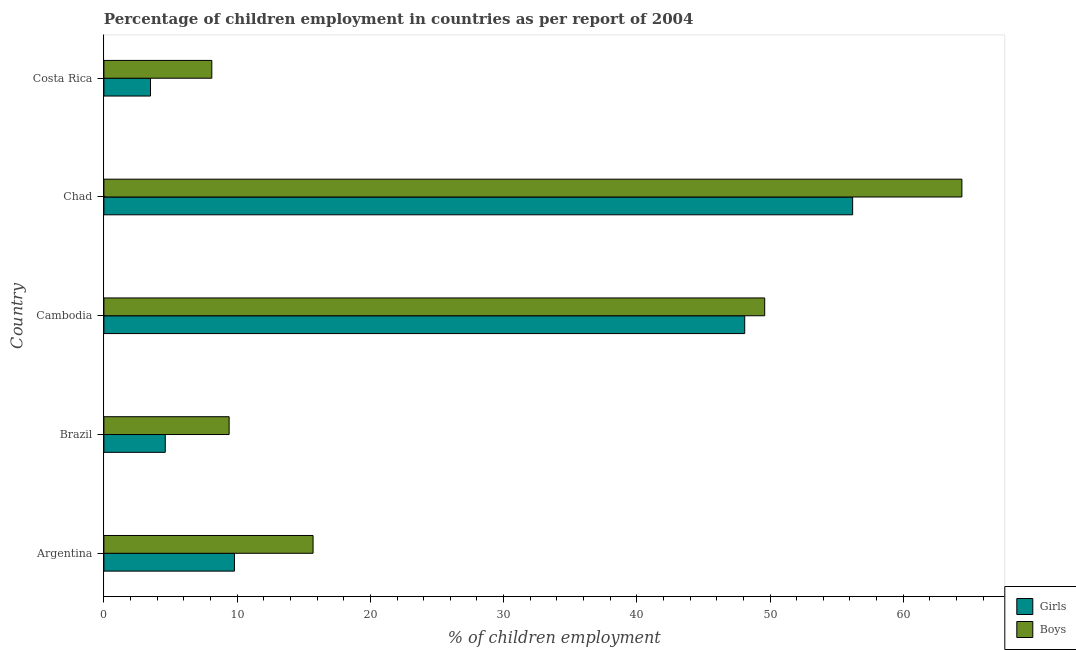How many different coloured bars are there?
Provide a short and direct response. 2. How many bars are there on the 1st tick from the top?
Make the answer very short. 2. How many bars are there on the 3rd tick from the bottom?
Your answer should be very brief. 2. What is the label of the 2nd group of bars from the top?
Provide a short and direct response. Chad. Across all countries, what is the maximum percentage of employed boys?
Provide a short and direct response. 64.4. In which country was the percentage of employed boys maximum?
Offer a very short reply. Chad. In which country was the percentage of employed boys minimum?
Your response must be concise. Costa Rica. What is the total percentage of employed boys in the graph?
Your answer should be very brief. 147.2. What is the difference between the percentage of employed girls in Costa Rica and the percentage of employed boys in Chad?
Provide a short and direct response. -60.9. What is the average percentage of employed boys per country?
Your response must be concise. 29.44. What is the ratio of the percentage of employed girls in Brazil to that in Costa Rica?
Make the answer very short. 1.32. What is the difference between the highest and the lowest percentage of employed girls?
Your response must be concise. 52.7. In how many countries, is the percentage of employed girls greater than the average percentage of employed girls taken over all countries?
Provide a short and direct response. 2. Is the sum of the percentage of employed boys in Cambodia and Costa Rica greater than the maximum percentage of employed girls across all countries?
Your answer should be very brief. Yes. What does the 1st bar from the top in Brazil represents?
Keep it short and to the point. Boys. What does the 1st bar from the bottom in Chad represents?
Keep it short and to the point. Girls. Are all the bars in the graph horizontal?
Make the answer very short. Yes. How many countries are there in the graph?
Give a very brief answer. 5. What is the difference between two consecutive major ticks on the X-axis?
Give a very brief answer. 10. Does the graph contain any zero values?
Make the answer very short. No. Does the graph contain grids?
Provide a succinct answer. No. How many legend labels are there?
Make the answer very short. 2. How are the legend labels stacked?
Ensure brevity in your answer.  Vertical. What is the title of the graph?
Offer a very short reply. Percentage of children employment in countries as per report of 2004. Does "From human activities" appear as one of the legend labels in the graph?
Provide a succinct answer. No. What is the label or title of the X-axis?
Offer a very short reply. % of children employment. What is the label or title of the Y-axis?
Make the answer very short. Country. What is the % of children employment of Girls in Argentina?
Ensure brevity in your answer.  9.8. What is the % of children employment in Boys in Argentina?
Provide a succinct answer. 15.7. What is the % of children employment in Girls in Brazil?
Offer a very short reply. 4.61. What is the % of children employment in Girls in Cambodia?
Make the answer very short. 48.1. What is the % of children employment in Boys in Cambodia?
Make the answer very short. 49.6. What is the % of children employment of Girls in Chad?
Provide a short and direct response. 56.2. What is the % of children employment in Boys in Chad?
Make the answer very short. 64.4. Across all countries, what is the maximum % of children employment of Girls?
Offer a very short reply. 56.2. Across all countries, what is the maximum % of children employment in Boys?
Make the answer very short. 64.4. Across all countries, what is the minimum % of children employment of Girls?
Ensure brevity in your answer.  3.5. Across all countries, what is the minimum % of children employment of Boys?
Your response must be concise. 8.1. What is the total % of children employment in Girls in the graph?
Keep it short and to the point. 122.21. What is the total % of children employment of Boys in the graph?
Your answer should be compact. 147.2. What is the difference between the % of children employment of Girls in Argentina and that in Brazil?
Give a very brief answer. 5.19. What is the difference between the % of children employment in Girls in Argentina and that in Cambodia?
Make the answer very short. -38.3. What is the difference between the % of children employment of Boys in Argentina and that in Cambodia?
Offer a terse response. -33.9. What is the difference between the % of children employment of Girls in Argentina and that in Chad?
Offer a terse response. -46.4. What is the difference between the % of children employment in Boys in Argentina and that in Chad?
Offer a terse response. -48.7. What is the difference between the % of children employment of Girls in Argentina and that in Costa Rica?
Provide a short and direct response. 6.3. What is the difference between the % of children employment in Boys in Argentina and that in Costa Rica?
Your answer should be compact. 7.6. What is the difference between the % of children employment in Girls in Brazil and that in Cambodia?
Provide a short and direct response. -43.49. What is the difference between the % of children employment in Boys in Brazil and that in Cambodia?
Provide a short and direct response. -40.2. What is the difference between the % of children employment of Girls in Brazil and that in Chad?
Offer a terse response. -51.59. What is the difference between the % of children employment of Boys in Brazil and that in Chad?
Offer a terse response. -55. What is the difference between the % of children employment in Girls in Brazil and that in Costa Rica?
Provide a short and direct response. 1.11. What is the difference between the % of children employment in Boys in Brazil and that in Costa Rica?
Your response must be concise. 1.3. What is the difference between the % of children employment of Girls in Cambodia and that in Chad?
Your answer should be very brief. -8.1. What is the difference between the % of children employment of Boys in Cambodia and that in Chad?
Keep it short and to the point. -14.8. What is the difference between the % of children employment of Girls in Cambodia and that in Costa Rica?
Give a very brief answer. 44.6. What is the difference between the % of children employment of Boys in Cambodia and that in Costa Rica?
Give a very brief answer. 41.5. What is the difference between the % of children employment in Girls in Chad and that in Costa Rica?
Make the answer very short. 52.7. What is the difference between the % of children employment of Boys in Chad and that in Costa Rica?
Your answer should be compact. 56.3. What is the difference between the % of children employment of Girls in Argentina and the % of children employment of Boys in Cambodia?
Your answer should be compact. -39.8. What is the difference between the % of children employment of Girls in Argentina and the % of children employment of Boys in Chad?
Give a very brief answer. -54.6. What is the difference between the % of children employment in Girls in Brazil and the % of children employment in Boys in Cambodia?
Offer a terse response. -44.99. What is the difference between the % of children employment in Girls in Brazil and the % of children employment in Boys in Chad?
Make the answer very short. -59.79. What is the difference between the % of children employment of Girls in Brazil and the % of children employment of Boys in Costa Rica?
Ensure brevity in your answer.  -3.49. What is the difference between the % of children employment in Girls in Cambodia and the % of children employment in Boys in Chad?
Provide a succinct answer. -16.3. What is the difference between the % of children employment of Girls in Cambodia and the % of children employment of Boys in Costa Rica?
Offer a terse response. 40. What is the difference between the % of children employment in Girls in Chad and the % of children employment in Boys in Costa Rica?
Provide a short and direct response. 48.1. What is the average % of children employment of Girls per country?
Make the answer very short. 24.44. What is the average % of children employment of Boys per country?
Your response must be concise. 29.44. What is the difference between the % of children employment in Girls and % of children employment in Boys in Brazil?
Make the answer very short. -4.79. What is the difference between the % of children employment of Girls and % of children employment of Boys in Cambodia?
Offer a very short reply. -1.5. What is the difference between the % of children employment in Girls and % of children employment in Boys in Chad?
Provide a short and direct response. -8.2. What is the ratio of the % of children employment of Girls in Argentina to that in Brazil?
Provide a succinct answer. 2.13. What is the ratio of the % of children employment in Boys in Argentina to that in Brazil?
Give a very brief answer. 1.67. What is the ratio of the % of children employment in Girls in Argentina to that in Cambodia?
Ensure brevity in your answer.  0.2. What is the ratio of the % of children employment in Boys in Argentina to that in Cambodia?
Your response must be concise. 0.32. What is the ratio of the % of children employment in Girls in Argentina to that in Chad?
Keep it short and to the point. 0.17. What is the ratio of the % of children employment of Boys in Argentina to that in Chad?
Your response must be concise. 0.24. What is the ratio of the % of children employment of Boys in Argentina to that in Costa Rica?
Give a very brief answer. 1.94. What is the ratio of the % of children employment in Girls in Brazil to that in Cambodia?
Make the answer very short. 0.1. What is the ratio of the % of children employment of Boys in Brazil to that in Cambodia?
Provide a succinct answer. 0.19. What is the ratio of the % of children employment of Girls in Brazil to that in Chad?
Make the answer very short. 0.08. What is the ratio of the % of children employment in Boys in Brazil to that in Chad?
Provide a short and direct response. 0.15. What is the ratio of the % of children employment in Girls in Brazil to that in Costa Rica?
Your answer should be very brief. 1.32. What is the ratio of the % of children employment in Boys in Brazil to that in Costa Rica?
Provide a short and direct response. 1.16. What is the ratio of the % of children employment in Girls in Cambodia to that in Chad?
Provide a succinct answer. 0.86. What is the ratio of the % of children employment in Boys in Cambodia to that in Chad?
Provide a short and direct response. 0.77. What is the ratio of the % of children employment in Girls in Cambodia to that in Costa Rica?
Keep it short and to the point. 13.74. What is the ratio of the % of children employment of Boys in Cambodia to that in Costa Rica?
Keep it short and to the point. 6.12. What is the ratio of the % of children employment in Girls in Chad to that in Costa Rica?
Keep it short and to the point. 16.06. What is the ratio of the % of children employment in Boys in Chad to that in Costa Rica?
Offer a terse response. 7.95. What is the difference between the highest and the second highest % of children employment in Girls?
Your answer should be very brief. 8.1. What is the difference between the highest and the lowest % of children employment of Girls?
Give a very brief answer. 52.7. What is the difference between the highest and the lowest % of children employment of Boys?
Offer a very short reply. 56.3. 